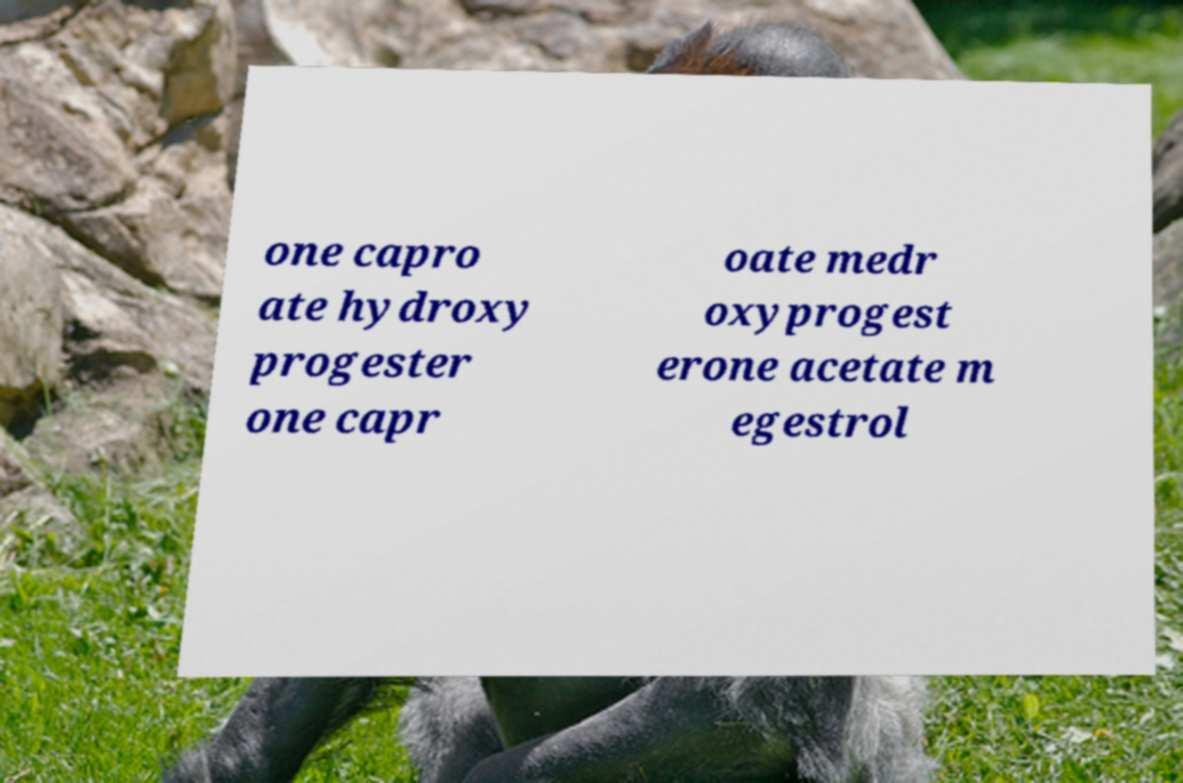There's text embedded in this image that I need extracted. Can you transcribe it verbatim? one capro ate hydroxy progester one capr oate medr oxyprogest erone acetate m egestrol 